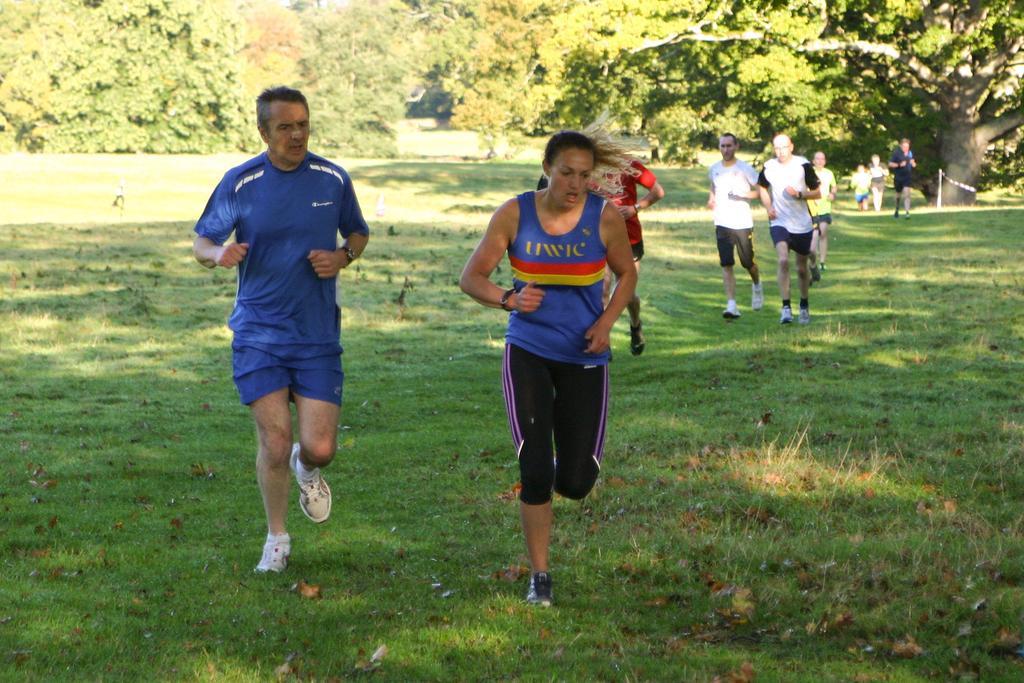Describe this image in one or two sentences. There are groups of people running. This is the grass. I can see the trees with branches and leaves. 